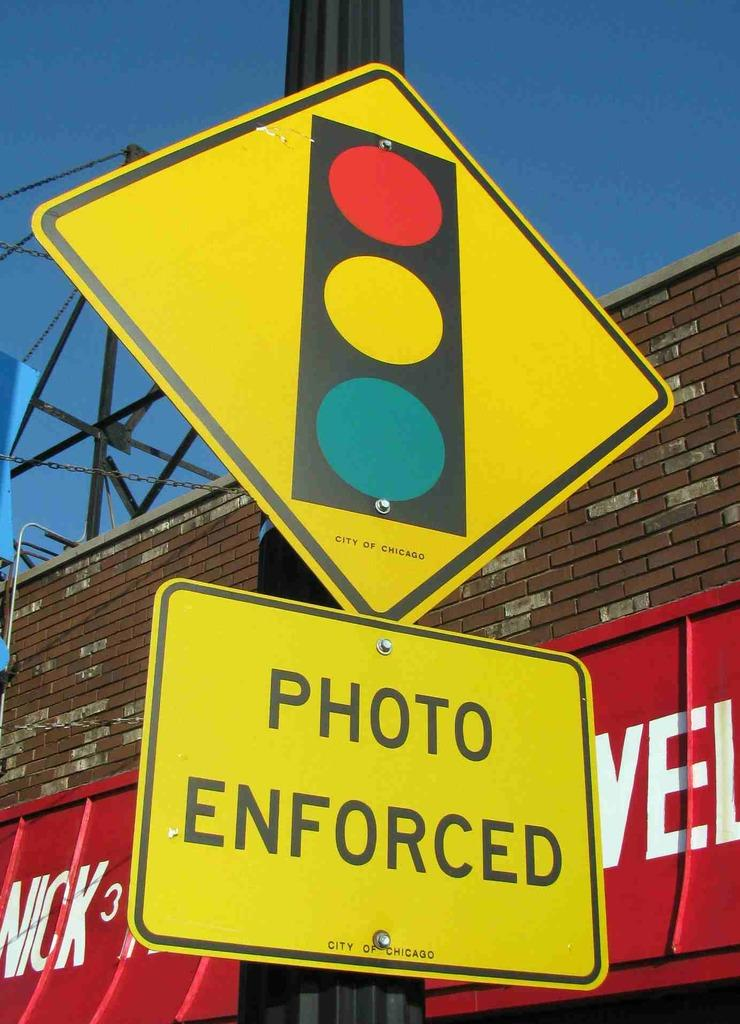<image>
Write a terse but informative summary of the picture. A yellow traffic sign on a black pole says Photo Enforced. 